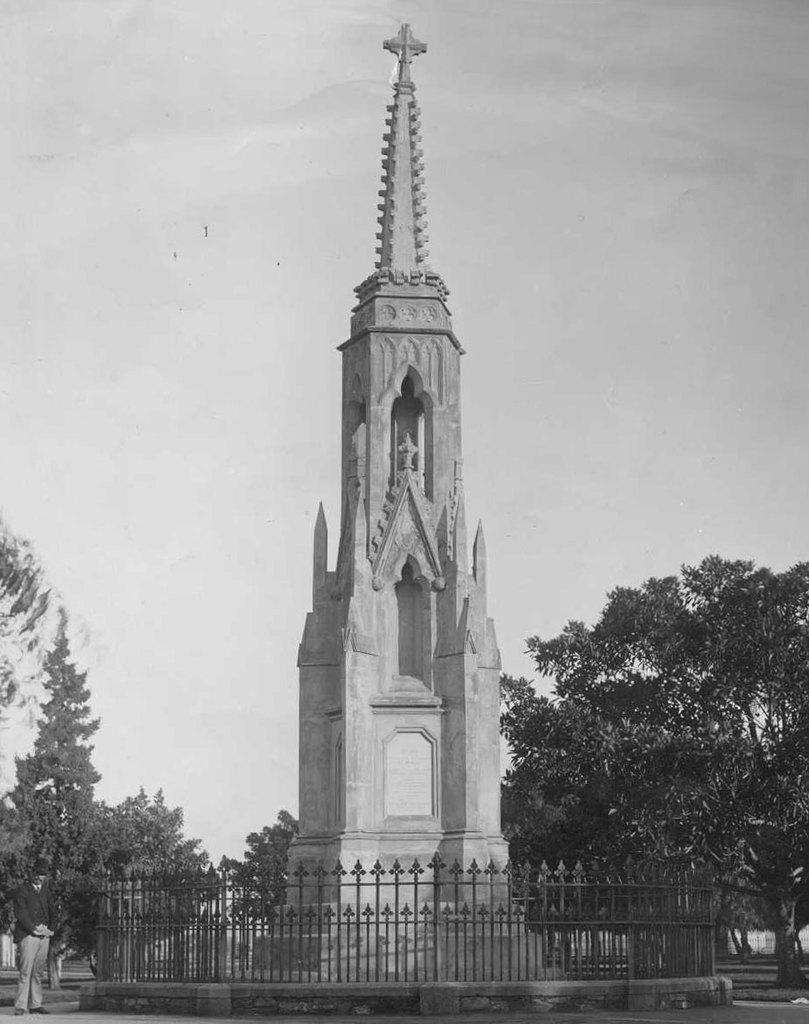Can you describe this image briefly? This picture shows a tower and we see a metal fence around it and few trees and a man standing. He wore a cap on his head and we see a cloudy sky. 